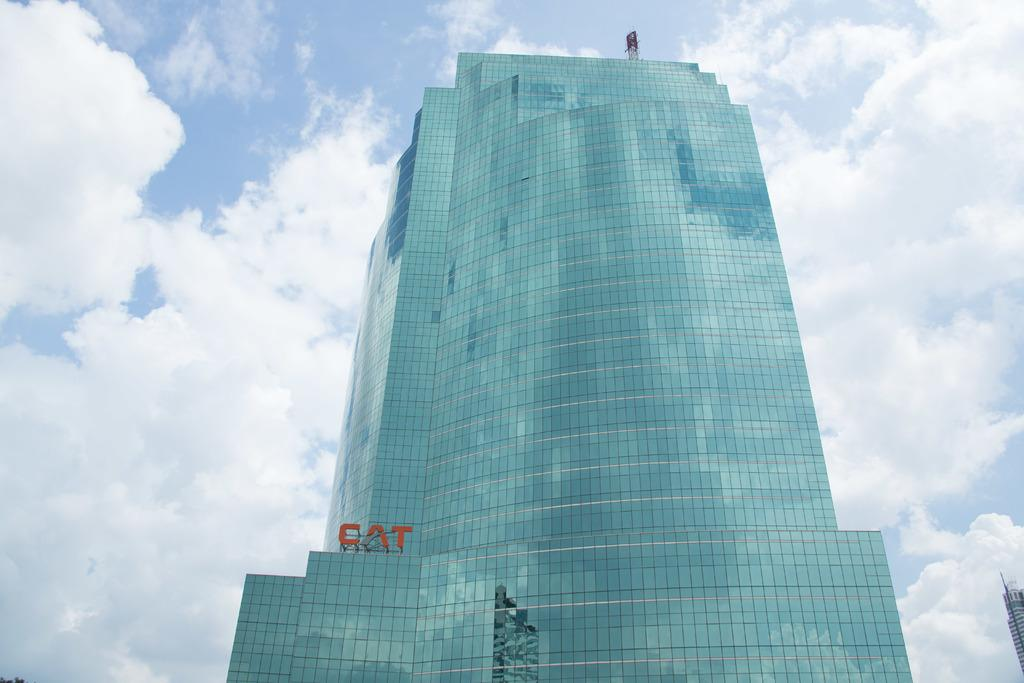<image>
Give a short and clear explanation of the subsequent image. A huge building with lots of windows and Cat on the building 